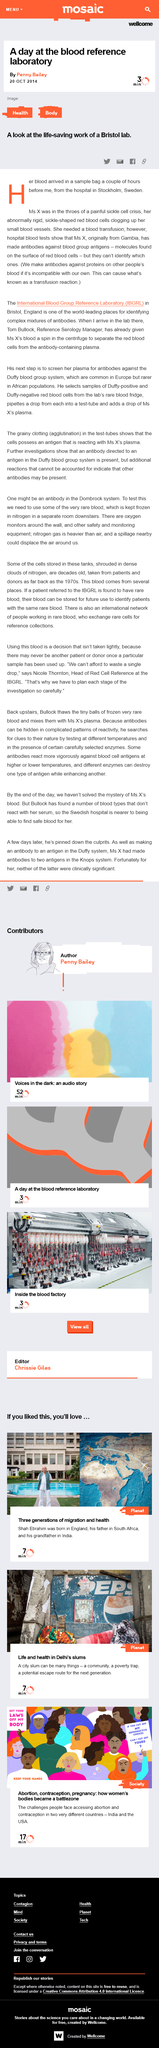Specify some key components in this picture. The location of the blood reference laboratory is in Bristol. It is confirmed that Ms X's blood sample was sent from Sweden. The individual known as Ms X is originally from Gambia. The slogans "Get your laws off my body" and "If you cut off my reproductive choices can I cut off yours?" are used to illustrate the concept that women's bodies have become a battlezone. Shah Ebrahim was born in England. 